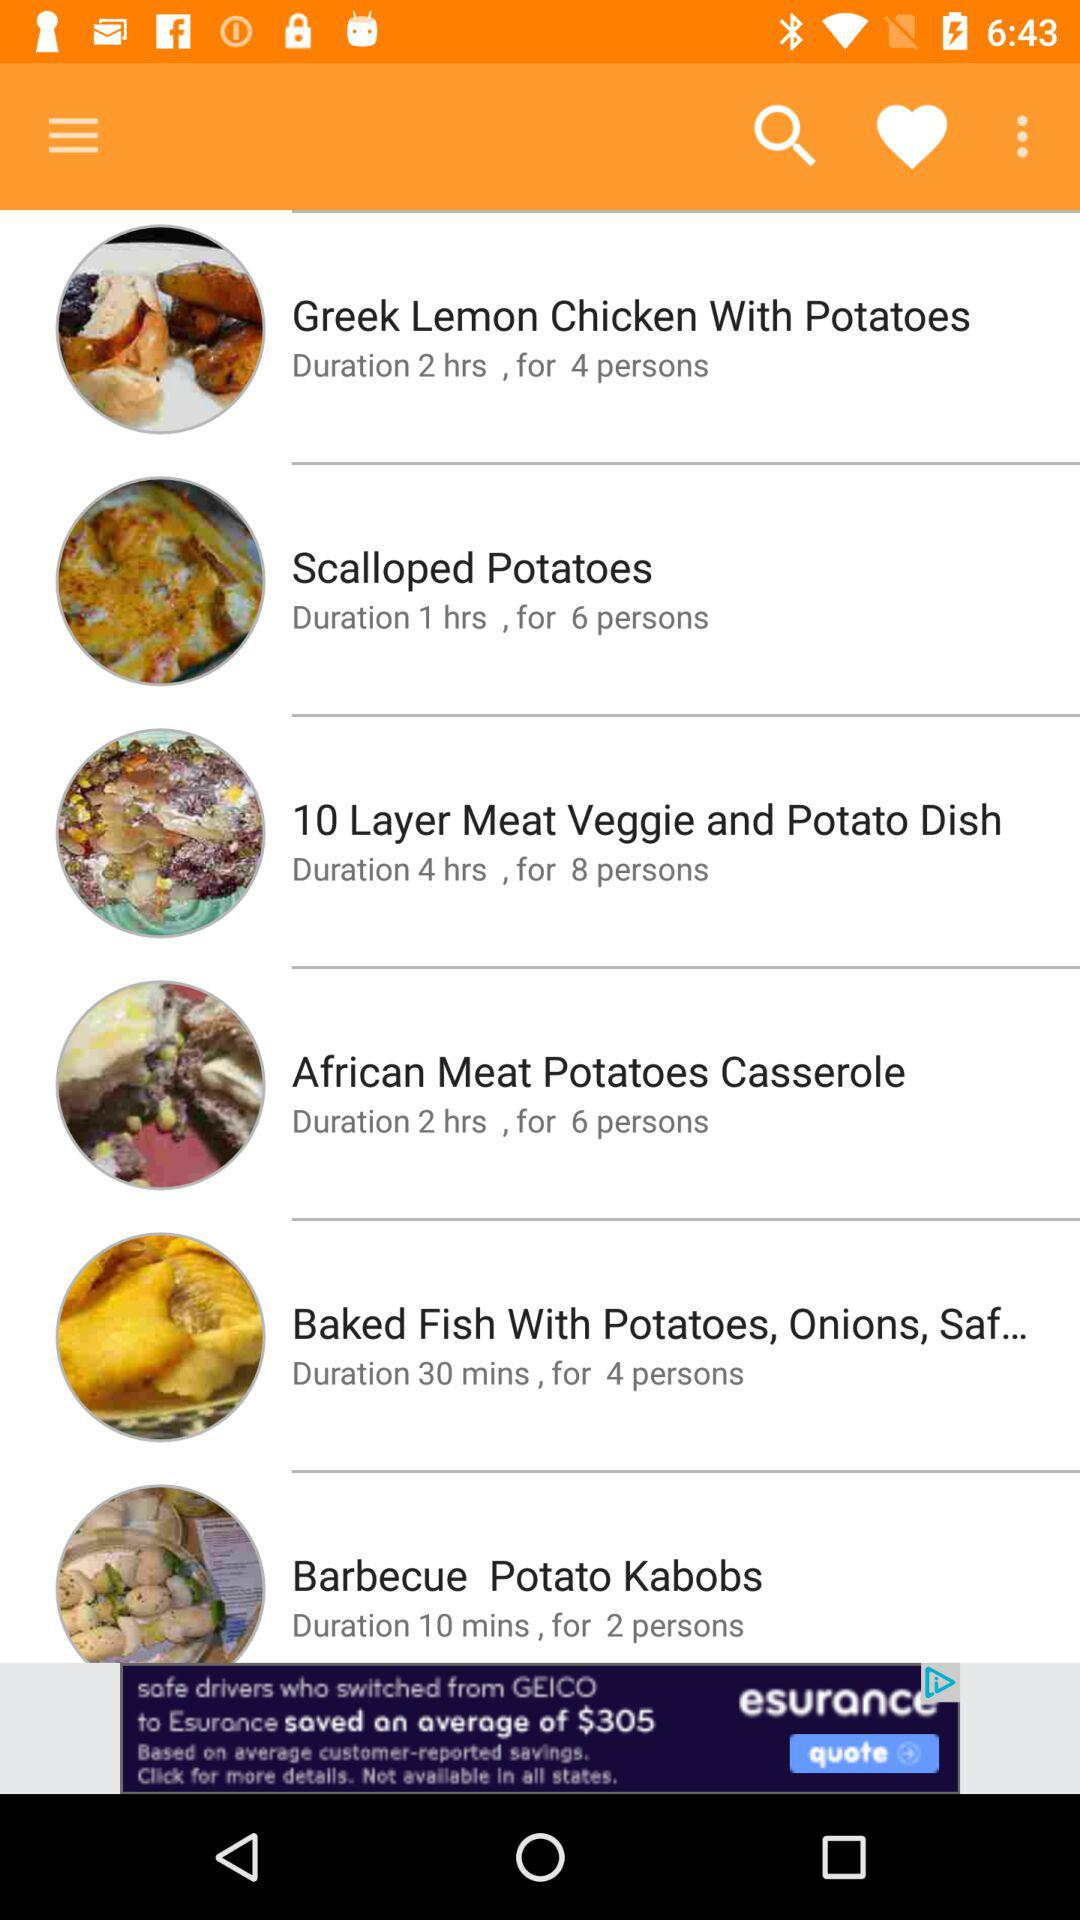What is the time duration for the recipe "Greek Lemon Chicken With Potatoes"? The time duration for the recipe is 2 hours. 